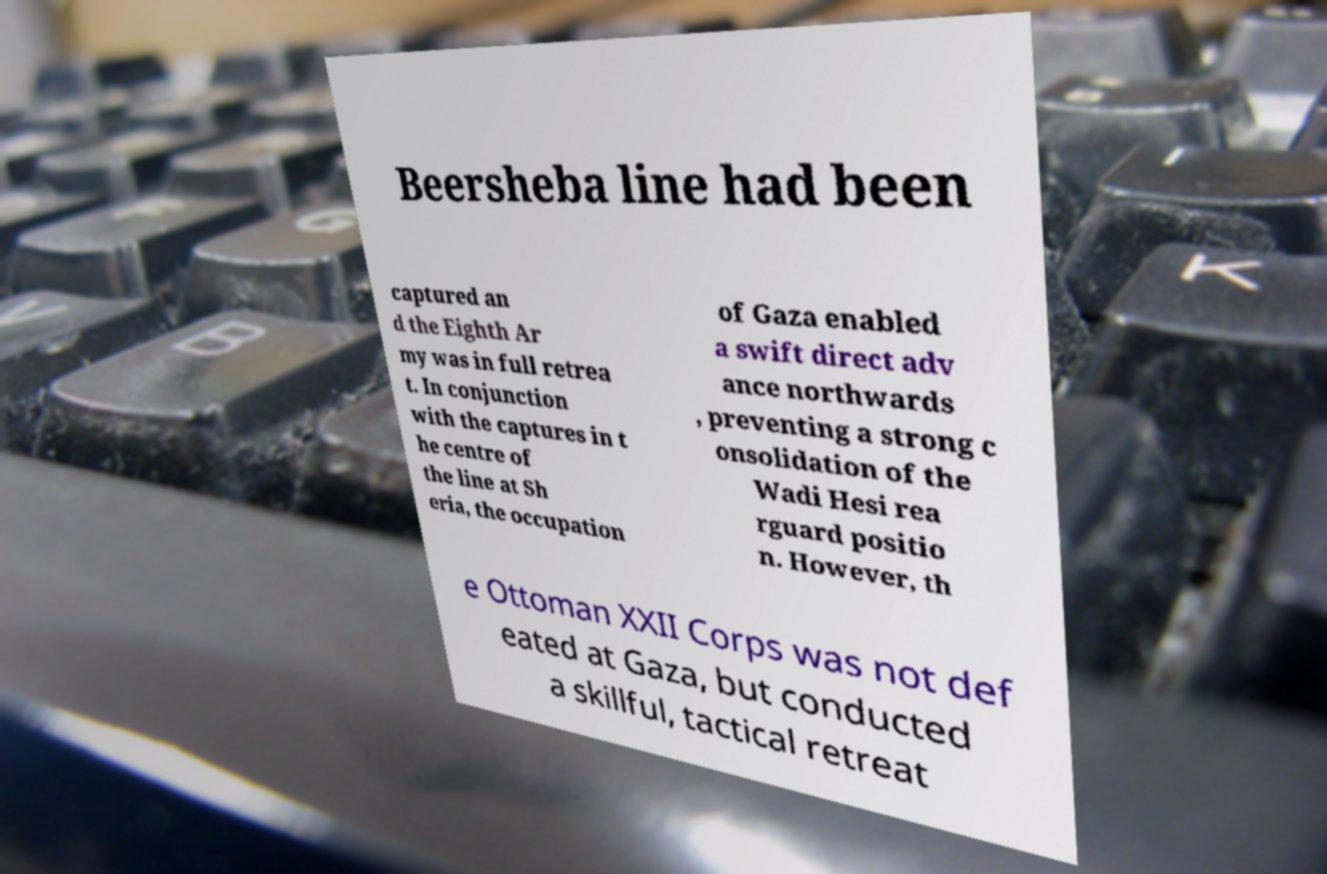Could you extract and type out the text from this image? Beersheba line had been captured an d the Eighth Ar my was in full retrea t. In conjunction with the captures in t he centre of the line at Sh eria, the occupation of Gaza enabled a swift direct adv ance northwards , preventing a strong c onsolidation of the Wadi Hesi rea rguard positio n. However, th e Ottoman XXII Corps was not def eated at Gaza, but conducted a skillful, tactical retreat 